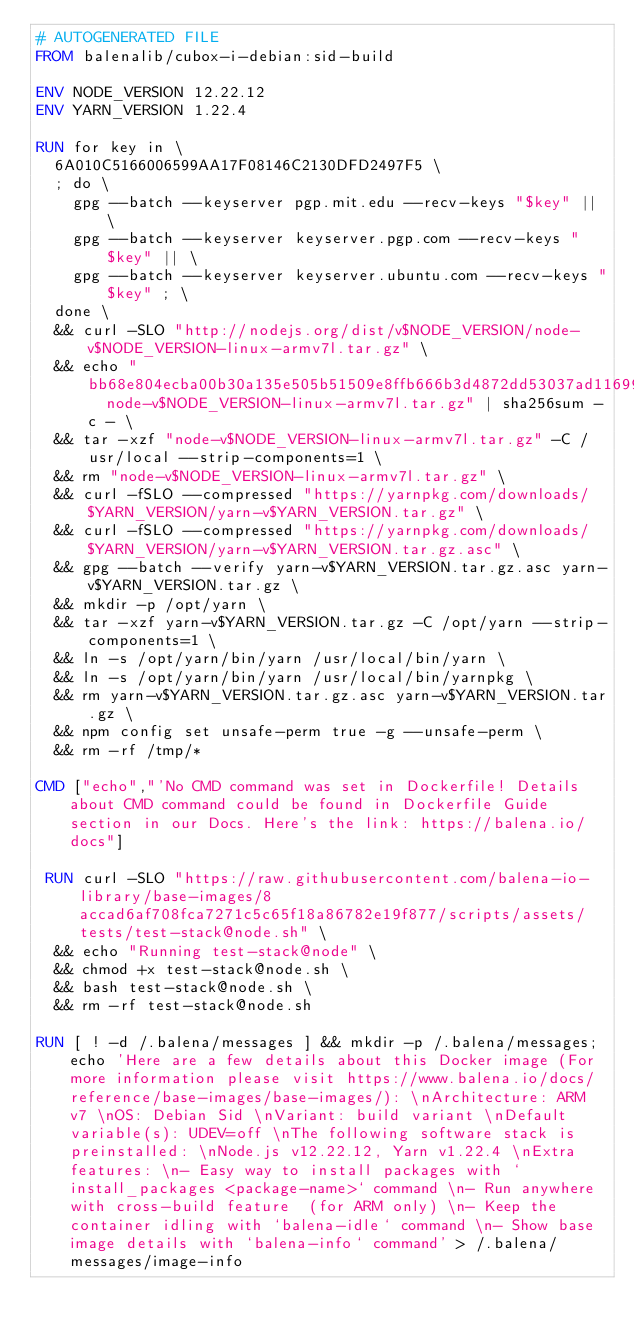Convert code to text. <code><loc_0><loc_0><loc_500><loc_500><_Dockerfile_># AUTOGENERATED FILE
FROM balenalib/cubox-i-debian:sid-build

ENV NODE_VERSION 12.22.12
ENV YARN_VERSION 1.22.4

RUN for key in \
	6A010C5166006599AA17F08146C2130DFD2497F5 \
	; do \
		gpg --batch --keyserver pgp.mit.edu --recv-keys "$key" || \
		gpg --batch --keyserver keyserver.pgp.com --recv-keys "$key" || \
		gpg --batch --keyserver keyserver.ubuntu.com --recv-keys "$key" ; \
	done \
	&& curl -SLO "http://nodejs.org/dist/v$NODE_VERSION/node-v$NODE_VERSION-linux-armv7l.tar.gz" \
	&& echo "bb68e804ecba00b30a135e505b51509e8ffb666b3d4872dd53037ad11699174c  node-v$NODE_VERSION-linux-armv7l.tar.gz" | sha256sum -c - \
	&& tar -xzf "node-v$NODE_VERSION-linux-armv7l.tar.gz" -C /usr/local --strip-components=1 \
	&& rm "node-v$NODE_VERSION-linux-armv7l.tar.gz" \
	&& curl -fSLO --compressed "https://yarnpkg.com/downloads/$YARN_VERSION/yarn-v$YARN_VERSION.tar.gz" \
	&& curl -fSLO --compressed "https://yarnpkg.com/downloads/$YARN_VERSION/yarn-v$YARN_VERSION.tar.gz.asc" \
	&& gpg --batch --verify yarn-v$YARN_VERSION.tar.gz.asc yarn-v$YARN_VERSION.tar.gz \
	&& mkdir -p /opt/yarn \
	&& tar -xzf yarn-v$YARN_VERSION.tar.gz -C /opt/yarn --strip-components=1 \
	&& ln -s /opt/yarn/bin/yarn /usr/local/bin/yarn \
	&& ln -s /opt/yarn/bin/yarn /usr/local/bin/yarnpkg \
	&& rm yarn-v$YARN_VERSION.tar.gz.asc yarn-v$YARN_VERSION.tar.gz \
	&& npm config set unsafe-perm true -g --unsafe-perm \
	&& rm -rf /tmp/*

CMD ["echo","'No CMD command was set in Dockerfile! Details about CMD command could be found in Dockerfile Guide section in our Docs. Here's the link: https://balena.io/docs"]

 RUN curl -SLO "https://raw.githubusercontent.com/balena-io-library/base-images/8accad6af708fca7271c5c65f18a86782e19f877/scripts/assets/tests/test-stack@node.sh" \
  && echo "Running test-stack@node" \
  && chmod +x test-stack@node.sh \
  && bash test-stack@node.sh \
  && rm -rf test-stack@node.sh 

RUN [ ! -d /.balena/messages ] && mkdir -p /.balena/messages; echo 'Here are a few details about this Docker image (For more information please visit https://www.balena.io/docs/reference/base-images/base-images/): \nArchitecture: ARM v7 \nOS: Debian Sid \nVariant: build variant \nDefault variable(s): UDEV=off \nThe following software stack is preinstalled: \nNode.js v12.22.12, Yarn v1.22.4 \nExtra features: \n- Easy way to install packages with `install_packages <package-name>` command \n- Run anywhere with cross-build feature  (for ARM only) \n- Keep the container idling with `balena-idle` command \n- Show base image details with `balena-info` command' > /.balena/messages/image-info</code> 